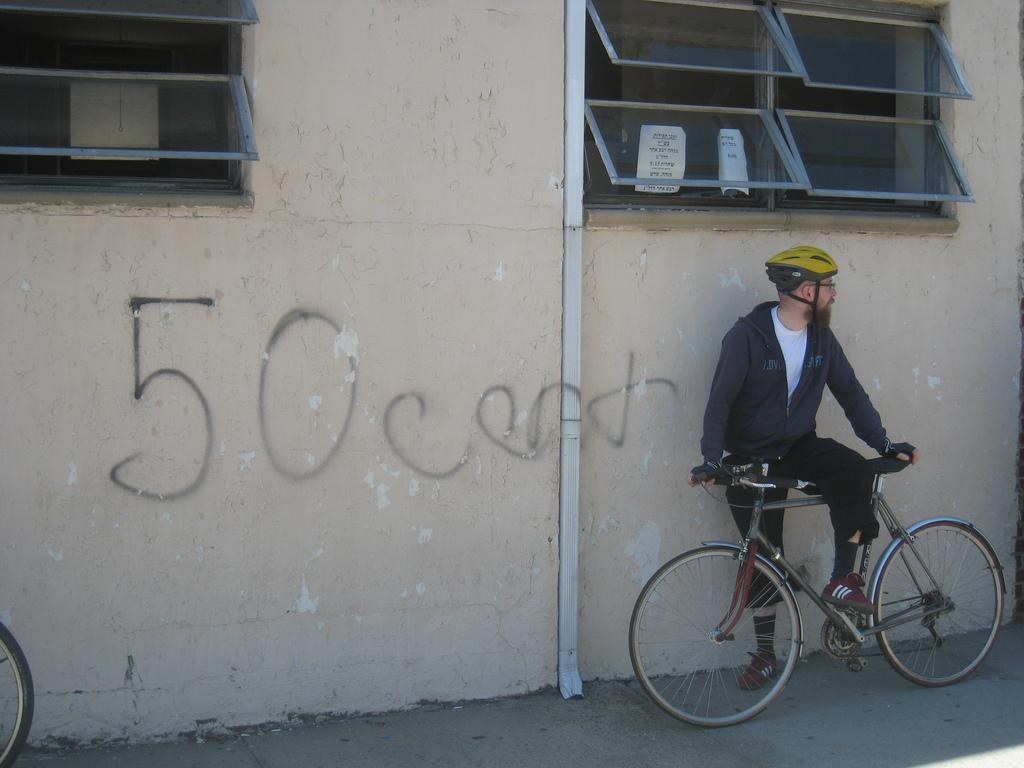Please provide a concise description of this image. In this picture outside of house. He is standing. His holding bicycle handle,His wearing helmet. We can see in background window,wall. 